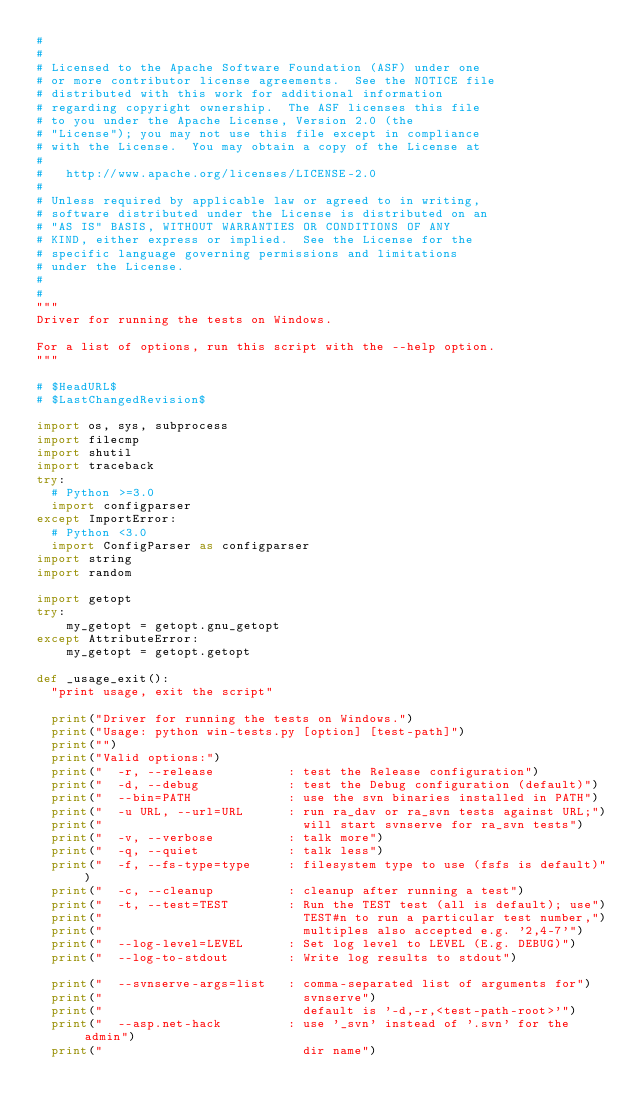Convert code to text. <code><loc_0><loc_0><loc_500><loc_500><_Python_>#
#
# Licensed to the Apache Software Foundation (ASF) under one
# or more contributor license agreements.  See the NOTICE file
# distributed with this work for additional information
# regarding copyright ownership.  The ASF licenses this file
# to you under the Apache License, Version 2.0 (the
# "License"); you may not use this file except in compliance
# with the License.  You may obtain a copy of the License at
#
#   http://www.apache.org/licenses/LICENSE-2.0
#
# Unless required by applicable law or agreed to in writing,
# software distributed under the License is distributed on an
# "AS IS" BASIS, WITHOUT WARRANTIES OR CONDITIONS OF ANY
# KIND, either express or implied.  See the License for the
# specific language governing permissions and limitations
# under the License.
#
#
"""
Driver for running the tests on Windows.

For a list of options, run this script with the --help option.
"""

# $HeadURL$
# $LastChangedRevision$

import os, sys, subprocess
import filecmp
import shutil
import traceback
try:
  # Python >=3.0
  import configparser
except ImportError:
  # Python <3.0
  import ConfigParser as configparser
import string
import random

import getopt
try:
    my_getopt = getopt.gnu_getopt
except AttributeError:
    my_getopt = getopt.getopt

def _usage_exit():
  "print usage, exit the script"

  print("Driver for running the tests on Windows.")
  print("Usage: python win-tests.py [option] [test-path]")
  print("")
  print("Valid options:")
  print("  -r, --release          : test the Release configuration")
  print("  -d, --debug            : test the Debug configuration (default)")
  print("  --bin=PATH             : use the svn binaries installed in PATH")
  print("  -u URL, --url=URL      : run ra_dav or ra_svn tests against URL;")
  print("                           will start svnserve for ra_svn tests")
  print("  -v, --verbose          : talk more")
  print("  -q, --quiet            : talk less")
  print("  -f, --fs-type=type     : filesystem type to use (fsfs is default)")
  print("  -c, --cleanup          : cleanup after running a test")
  print("  -t, --test=TEST        : Run the TEST test (all is default); use")
  print("                           TEST#n to run a particular test number,")
  print("                           multiples also accepted e.g. '2,4-7'")
  print("  --log-level=LEVEL      : Set log level to LEVEL (E.g. DEBUG)")
  print("  --log-to-stdout        : Write log results to stdout")

  print("  --svnserve-args=list   : comma-separated list of arguments for")
  print("                           svnserve")
  print("                           default is '-d,-r,<test-path-root>'")
  print("  --asp.net-hack         : use '_svn' instead of '.svn' for the admin")
  print("                           dir name")</code> 